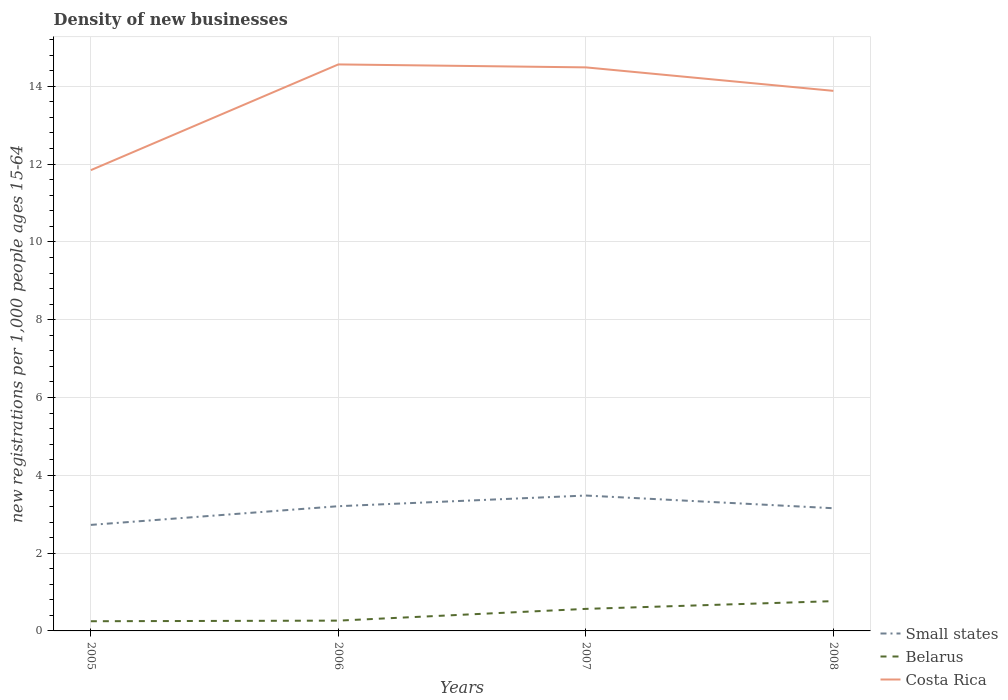Does the line corresponding to Small states intersect with the line corresponding to Costa Rica?
Provide a short and direct response. No. Across all years, what is the maximum number of new registrations in Small states?
Offer a terse response. 2.73. What is the total number of new registrations in Belarus in the graph?
Your answer should be compact. -0.32. What is the difference between the highest and the second highest number of new registrations in Costa Rica?
Ensure brevity in your answer.  2.72. What is the difference between the highest and the lowest number of new registrations in Costa Rica?
Give a very brief answer. 3. What is the difference between two consecutive major ticks on the Y-axis?
Make the answer very short. 2. Are the values on the major ticks of Y-axis written in scientific E-notation?
Make the answer very short. No. Does the graph contain any zero values?
Provide a succinct answer. No. How are the legend labels stacked?
Ensure brevity in your answer.  Vertical. What is the title of the graph?
Give a very brief answer. Density of new businesses. Does "Lebanon" appear as one of the legend labels in the graph?
Provide a succinct answer. No. What is the label or title of the Y-axis?
Keep it short and to the point. New registrations per 1,0 people ages 15-64. What is the new registrations per 1,000 people ages 15-64 of Small states in 2005?
Give a very brief answer. 2.73. What is the new registrations per 1,000 people ages 15-64 in Belarus in 2005?
Your answer should be compact. 0.25. What is the new registrations per 1,000 people ages 15-64 in Costa Rica in 2005?
Offer a terse response. 11.84. What is the new registrations per 1,000 people ages 15-64 in Small states in 2006?
Provide a short and direct response. 3.21. What is the new registrations per 1,000 people ages 15-64 in Belarus in 2006?
Make the answer very short. 0.26. What is the new registrations per 1,000 people ages 15-64 in Costa Rica in 2006?
Offer a very short reply. 14.56. What is the new registrations per 1,000 people ages 15-64 in Small states in 2007?
Ensure brevity in your answer.  3.48. What is the new registrations per 1,000 people ages 15-64 in Belarus in 2007?
Your response must be concise. 0.57. What is the new registrations per 1,000 people ages 15-64 of Costa Rica in 2007?
Your response must be concise. 14.49. What is the new registrations per 1,000 people ages 15-64 of Small states in 2008?
Offer a very short reply. 3.15. What is the new registrations per 1,000 people ages 15-64 of Belarus in 2008?
Your answer should be compact. 0.77. What is the new registrations per 1,000 people ages 15-64 in Costa Rica in 2008?
Your answer should be compact. 13.88. Across all years, what is the maximum new registrations per 1,000 people ages 15-64 of Small states?
Offer a terse response. 3.48. Across all years, what is the maximum new registrations per 1,000 people ages 15-64 in Belarus?
Give a very brief answer. 0.77. Across all years, what is the maximum new registrations per 1,000 people ages 15-64 in Costa Rica?
Offer a terse response. 14.56. Across all years, what is the minimum new registrations per 1,000 people ages 15-64 in Small states?
Provide a short and direct response. 2.73. Across all years, what is the minimum new registrations per 1,000 people ages 15-64 in Belarus?
Give a very brief answer. 0.25. Across all years, what is the minimum new registrations per 1,000 people ages 15-64 in Costa Rica?
Your response must be concise. 11.84. What is the total new registrations per 1,000 people ages 15-64 in Small states in the graph?
Keep it short and to the point. 12.57. What is the total new registrations per 1,000 people ages 15-64 of Belarus in the graph?
Your response must be concise. 1.85. What is the total new registrations per 1,000 people ages 15-64 in Costa Rica in the graph?
Make the answer very short. 54.78. What is the difference between the new registrations per 1,000 people ages 15-64 in Small states in 2005 and that in 2006?
Ensure brevity in your answer.  -0.48. What is the difference between the new registrations per 1,000 people ages 15-64 in Belarus in 2005 and that in 2006?
Offer a very short reply. -0.02. What is the difference between the new registrations per 1,000 people ages 15-64 in Costa Rica in 2005 and that in 2006?
Your response must be concise. -2.72. What is the difference between the new registrations per 1,000 people ages 15-64 in Small states in 2005 and that in 2007?
Keep it short and to the point. -0.75. What is the difference between the new registrations per 1,000 people ages 15-64 of Belarus in 2005 and that in 2007?
Offer a very short reply. -0.32. What is the difference between the new registrations per 1,000 people ages 15-64 of Costa Rica in 2005 and that in 2007?
Provide a short and direct response. -2.64. What is the difference between the new registrations per 1,000 people ages 15-64 of Small states in 2005 and that in 2008?
Your answer should be very brief. -0.43. What is the difference between the new registrations per 1,000 people ages 15-64 of Belarus in 2005 and that in 2008?
Provide a succinct answer. -0.52. What is the difference between the new registrations per 1,000 people ages 15-64 in Costa Rica in 2005 and that in 2008?
Your answer should be compact. -2.04. What is the difference between the new registrations per 1,000 people ages 15-64 of Small states in 2006 and that in 2007?
Ensure brevity in your answer.  -0.27. What is the difference between the new registrations per 1,000 people ages 15-64 in Belarus in 2006 and that in 2007?
Your answer should be very brief. -0.3. What is the difference between the new registrations per 1,000 people ages 15-64 of Costa Rica in 2006 and that in 2007?
Your answer should be compact. 0.08. What is the difference between the new registrations per 1,000 people ages 15-64 in Small states in 2006 and that in 2008?
Provide a succinct answer. 0.05. What is the difference between the new registrations per 1,000 people ages 15-64 of Belarus in 2006 and that in 2008?
Offer a terse response. -0.5. What is the difference between the new registrations per 1,000 people ages 15-64 in Costa Rica in 2006 and that in 2008?
Your answer should be compact. 0.68. What is the difference between the new registrations per 1,000 people ages 15-64 in Small states in 2007 and that in 2008?
Your response must be concise. 0.33. What is the difference between the new registrations per 1,000 people ages 15-64 of Belarus in 2007 and that in 2008?
Make the answer very short. -0.2. What is the difference between the new registrations per 1,000 people ages 15-64 in Costa Rica in 2007 and that in 2008?
Ensure brevity in your answer.  0.6. What is the difference between the new registrations per 1,000 people ages 15-64 in Small states in 2005 and the new registrations per 1,000 people ages 15-64 in Belarus in 2006?
Your answer should be very brief. 2.46. What is the difference between the new registrations per 1,000 people ages 15-64 of Small states in 2005 and the new registrations per 1,000 people ages 15-64 of Costa Rica in 2006?
Keep it short and to the point. -11.84. What is the difference between the new registrations per 1,000 people ages 15-64 of Belarus in 2005 and the new registrations per 1,000 people ages 15-64 of Costa Rica in 2006?
Make the answer very short. -14.31. What is the difference between the new registrations per 1,000 people ages 15-64 of Small states in 2005 and the new registrations per 1,000 people ages 15-64 of Belarus in 2007?
Offer a terse response. 2.16. What is the difference between the new registrations per 1,000 people ages 15-64 of Small states in 2005 and the new registrations per 1,000 people ages 15-64 of Costa Rica in 2007?
Provide a succinct answer. -11.76. What is the difference between the new registrations per 1,000 people ages 15-64 in Belarus in 2005 and the new registrations per 1,000 people ages 15-64 in Costa Rica in 2007?
Your answer should be compact. -14.24. What is the difference between the new registrations per 1,000 people ages 15-64 in Small states in 2005 and the new registrations per 1,000 people ages 15-64 in Belarus in 2008?
Provide a succinct answer. 1.96. What is the difference between the new registrations per 1,000 people ages 15-64 in Small states in 2005 and the new registrations per 1,000 people ages 15-64 in Costa Rica in 2008?
Provide a succinct answer. -11.16. What is the difference between the new registrations per 1,000 people ages 15-64 in Belarus in 2005 and the new registrations per 1,000 people ages 15-64 in Costa Rica in 2008?
Provide a succinct answer. -13.63. What is the difference between the new registrations per 1,000 people ages 15-64 of Small states in 2006 and the new registrations per 1,000 people ages 15-64 of Belarus in 2007?
Keep it short and to the point. 2.64. What is the difference between the new registrations per 1,000 people ages 15-64 in Small states in 2006 and the new registrations per 1,000 people ages 15-64 in Costa Rica in 2007?
Offer a very short reply. -11.28. What is the difference between the new registrations per 1,000 people ages 15-64 in Belarus in 2006 and the new registrations per 1,000 people ages 15-64 in Costa Rica in 2007?
Keep it short and to the point. -14.22. What is the difference between the new registrations per 1,000 people ages 15-64 of Small states in 2006 and the new registrations per 1,000 people ages 15-64 of Belarus in 2008?
Keep it short and to the point. 2.44. What is the difference between the new registrations per 1,000 people ages 15-64 of Small states in 2006 and the new registrations per 1,000 people ages 15-64 of Costa Rica in 2008?
Ensure brevity in your answer.  -10.68. What is the difference between the new registrations per 1,000 people ages 15-64 of Belarus in 2006 and the new registrations per 1,000 people ages 15-64 of Costa Rica in 2008?
Make the answer very short. -13.62. What is the difference between the new registrations per 1,000 people ages 15-64 in Small states in 2007 and the new registrations per 1,000 people ages 15-64 in Belarus in 2008?
Provide a succinct answer. 2.71. What is the difference between the new registrations per 1,000 people ages 15-64 in Small states in 2007 and the new registrations per 1,000 people ages 15-64 in Costa Rica in 2008?
Provide a succinct answer. -10.4. What is the difference between the new registrations per 1,000 people ages 15-64 in Belarus in 2007 and the new registrations per 1,000 people ages 15-64 in Costa Rica in 2008?
Make the answer very short. -13.32. What is the average new registrations per 1,000 people ages 15-64 in Small states per year?
Make the answer very short. 3.14. What is the average new registrations per 1,000 people ages 15-64 in Belarus per year?
Your answer should be very brief. 0.46. What is the average new registrations per 1,000 people ages 15-64 of Costa Rica per year?
Offer a very short reply. 13.69. In the year 2005, what is the difference between the new registrations per 1,000 people ages 15-64 in Small states and new registrations per 1,000 people ages 15-64 in Belarus?
Ensure brevity in your answer.  2.48. In the year 2005, what is the difference between the new registrations per 1,000 people ages 15-64 in Small states and new registrations per 1,000 people ages 15-64 in Costa Rica?
Your answer should be compact. -9.12. In the year 2005, what is the difference between the new registrations per 1,000 people ages 15-64 in Belarus and new registrations per 1,000 people ages 15-64 in Costa Rica?
Your answer should be very brief. -11.6. In the year 2006, what is the difference between the new registrations per 1,000 people ages 15-64 in Small states and new registrations per 1,000 people ages 15-64 in Belarus?
Provide a short and direct response. 2.94. In the year 2006, what is the difference between the new registrations per 1,000 people ages 15-64 of Small states and new registrations per 1,000 people ages 15-64 of Costa Rica?
Your answer should be very brief. -11.36. In the year 2006, what is the difference between the new registrations per 1,000 people ages 15-64 in Belarus and new registrations per 1,000 people ages 15-64 in Costa Rica?
Your answer should be very brief. -14.3. In the year 2007, what is the difference between the new registrations per 1,000 people ages 15-64 of Small states and new registrations per 1,000 people ages 15-64 of Belarus?
Your answer should be compact. 2.91. In the year 2007, what is the difference between the new registrations per 1,000 people ages 15-64 of Small states and new registrations per 1,000 people ages 15-64 of Costa Rica?
Your answer should be very brief. -11.01. In the year 2007, what is the difference between the new registrations per 1,000 people ages 15-64 in Belarus and new registrations per 1,000 people ages 15-64 in Costa Rica?
Make the answer very short. -13.92. In the year 2008, what is the difference between the new registrations per 1,000 people ages 15-64 in Small states and new registrations per 1,000 people ages 15-64 in Belarus?
Provide a succinct answer. 2.39. In the year 2008, what is the difference between the new registrations per 1,000 people ages 15-64 of Small states and new registrations per 1,000 people ages 15-64 of Costa Rica?
Your response must be concise. -10.73. In the year 2008, what is the difference between the new registrations per 1,000 people ages 15-64 of Belarus and new registrations per 1,000 people ages 15-64 of Costa Rica?
Offer a terse response. -13.12. What is the ratio of the new registrations per 1,000 people ages 15-64 in Small states in 2005 to that in 2006?
Your answer should be very brief. 0.85. What is the ratio of the new registrations per 1,000 people ages 15-64 of Belarus in 2005 to that in 2006?
Keep it short and to the point. 0.94. What is the ratio of the new registrations per 1,000 people ages 15-64 of Costa Rica in 2005 to that in 2006?
Your answer should be very brief. 0.81. What is the ratio of the new registrations per 1,000 people ages 15-64 of Small states in 2005 to that in 2007?
Ensure brevity in your answer.  0.78. What is the ratio of the new registrations per 1,000 people ages 15-64 in Belarus in 2005 to that in 2007?
Offer a very short reply. 0.44. What is the ratio of the new registrations per 1,000 people ages 15-64 in Costa Rica in 2005 to that in 2007?
Your answer should be compact. 0.82. What is the ratio of the new registrations per 1,000 people ages 15-64 in Small states in 2005 to that in 2008?
Provide a short and direct response. 0.86. What is the ratio of the new registrations per 1,000 people ages 15-64 of Belarus in 2005 to that in 2008?
Give a very brief answer. 0.33. What is the ratio of the new registrations per 1,000 people ages 15-64 of Costa Rica in 2005 to that in 2008?
Your answer should be compact. 0.85. What is the ratio of the new registrations per 1,000 people ages 15-64 in Small states in 2006 to that in 2007?
Keep it short and to the point. 0.92. What is the ratio of the new registrations per 1,000 people ages 15-64 in Belarus in 2006 to that in 2007?
Offer a very short reply. 0.47. What is the ratio of the new registrations per 1,000 people ages 15-64 of Small states in 2006 to that in 2008?
Give a very brief answer. 1.02. What is the ratio of the new registrations per 1,000 people ages 15-64 of Belarus in 2006 to that in 2008?
Ensure brevity in your answer.  0.35. What is the ratio of the new registrations per 1,000 people ages 15-64 in Costa Rica in 2006 to that in 2008?
Your answer should be compact. 1.05. What is the ratio of the new registrations per 1,000 people ages 15-64 of Small states in 2007 to that in 2008?
Offer a terse response. 1.1. What is the ratio of the new registrations per 1,000 people ages 15-64 in Belarus in 2007 to that in 2008?
Offer a very short reply. 0.74. What is the ratio of the new registrations per 1,000 people ages 15-64 in Costa Rica in 2007 to that in 2008?
Your answer should be very brief. 1.04. What is the difference between the highest and the second highest new registrations per 1,000 people ages 15-64 in Small states?
Offer a very short reply. 0.27. What is the difference between the highest and the second highest new registrations per 1,000 people ages 15-64 of Belarus?
Your answer should be compact. 0.2. What is the difference between the highest and the second highest new registrations per 1,000 people ages 15-64 of Costa Rica?
Provide a short and direct response. 0.08. What is the difference between the highest and the lowest new registrations per 1,000 people ages 15-64 of Small states?
Ensure brevity in your answer.  0.75. What is the difference between the highest and the lowest new registrations per 1,000 people ages 15-64 of Belarus?
Offer a terse response. 0.52. What is the difference between the highest and the lowest new registrations per 1,000 people ages 15-64 in Costa Rica?
Provide a succinct answer. 2.72. 